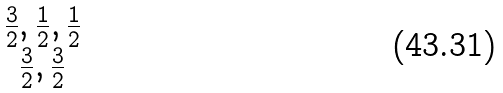Convert formula to latex. <formula><loc_0><loc_0><loc_500><loc_500>\begin{matrix} { \frac { 3 } { 2 } , \frac { 1 } { 2 } , \frac { 1 } { 2 } } \\ { \frac { 3 } { 2 } , \frac { 3 } { 2 } } \end{matrix}</formula> 